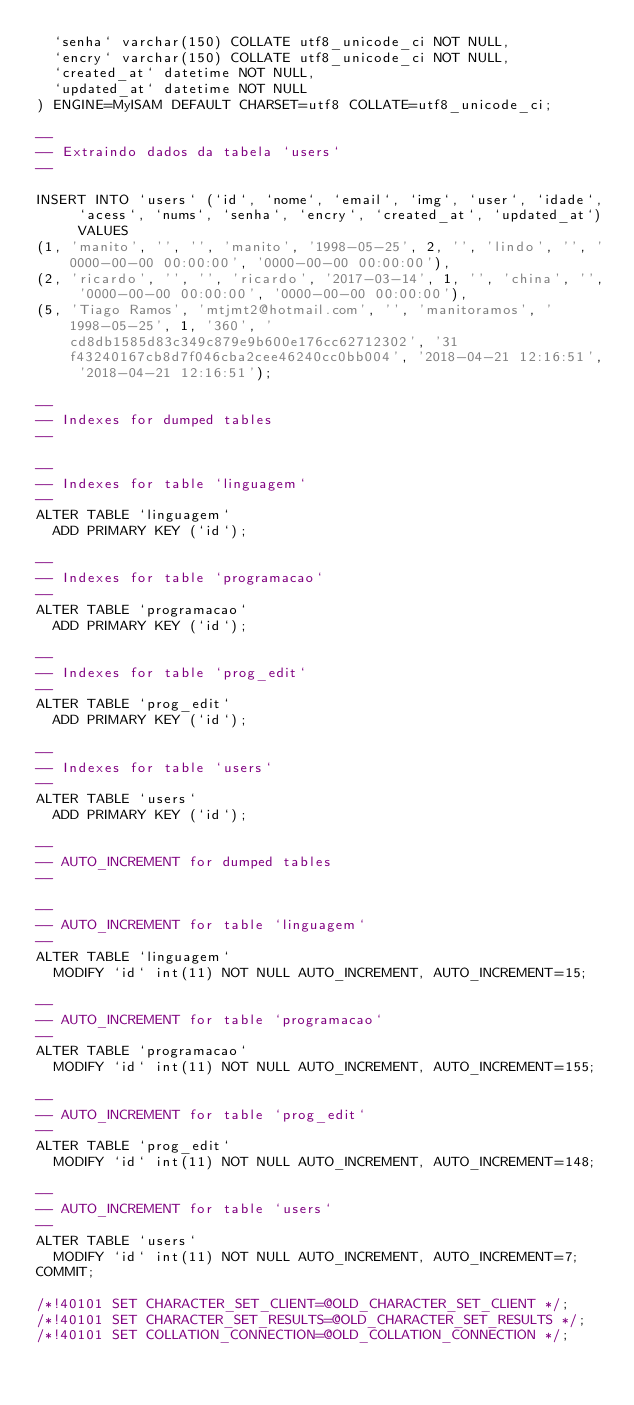Convert code to text. <code><loc_0><loc_0><loc_500><loc_500><_SQL_>  `senha` varchar(150) COLLATE utf8_unicode_ci NOT NULL,
  `encry` varchar(150) COLLATE utf8_unicode_ci NOT NULL,
  `created_at` datetime NOT NULL,
  `updated_at` datetime NOT NULL
) ENGINE=MyISAM DEFAULT CHARSET=utf8 COLLATE=utf8_unicode_ci;

--
-- Extraindo dados da tabela `users`
--

INSERT INTO `users` (`id`, `nome`, `email`, `img`, `user`, `idade`, `acess`, `nums`, `senha`, `encry`, `created_at`, `updated_at`) VALUES
(1, 'manito', '', '', 'manito', '1998-05-25', 2, '', 'lindo', '', '0000-00-00 00:00:00', '0000-00-00 00:00:00'),
(2, 'ricardo', '', '', 'ricardo', '2017-03-14', 1, '', 'china', '', '0000-00-00 00:00:00', '0000-00-00 00:00:00'),
(5, 'Tiago Ramos', 'mtjmt2@hotmail.com', '', 'manitoramos', '1998-05-25', 1, '360', 'cd8db1585d83c349c879e9b600e176cc62712302', '31f43240167cb8d7f046cba2cee46240cc0bb004', '2018-04-21 12:16:51', '2018-04-21 12:16:51');

--
-- Indexes for dumped tables
--

--
-- Indexes for table `linguagem`
--
ALTER TABLE `linguagem`
  ADD PRIMARY KEY (`id`);

--
-- Indexes for table `programacao`
--
ALTER TABLE `programacao`
  ADD PRIMARY KEY (`id`);

--
-- Indexes for table `prog_edit`
--
ALTER TABLE `prog_edit`
  ADD PRIMARY KEY (`id`);

--
-- Indexes for table `users`
--
ALTER TABLE `users`
  ADD PRIMARY KEY (`id`);

--
-- AUTO_INCREMENT for dumped tables
--

--
-- AUTO_INCREMENT for table `linguagem`
--
ALTER TABLE `linguagem`
  MODIFY `id` int(11) NOT NULL AUTO_INCREMENT, AUTO_INCREMENT=15;

--
-- AUTO_INCREMENT for table `programacao`
--
ALTER TABLE `programacao`
  MODIFY `id` int(11) NOT NULL AUTO_INCREMENT, AUTO_INCREMENT=155;

--
-- AUTO_INCREMENT for table `prog_edit`
--
ALTER TABLE `prog_edit`
  MODIFY `id` int(11) NOT NULL AUTO_INCREMENT, AUTO_INCREMENT=148;

--
-- AUTO_INCREMENT for table `users`
--
ALTER TABLE `users`
  MODIFY `id` int(11) NOT NULL AUTO_INCREMENT, AUTO_INCREMENT=7;
COMMIT;

/*!40101 SET CHARACTER_SET_CLIENT=@OLD_CHARACTER_SET_CLIENT */;
/*!40101 SET CHARACTER_SET_RESULTS=@OLD_CHARACTER_SET_RESULTS */;
/*!40101 SET COLLATION_CONNECTION=@OLD_COLLATION_CONNECTION */;
</code> 